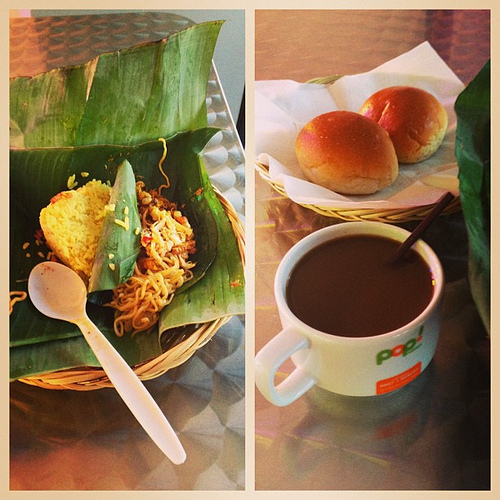What is the color of the table? The table's surface glistens with a silver hue that reflects the ambient light, adding a modern touch to the dining experience. 